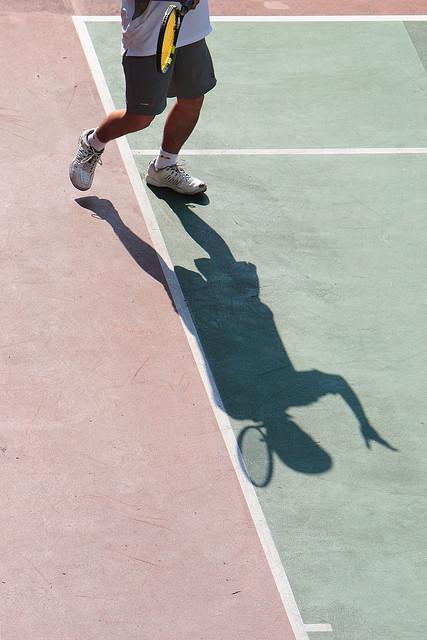How many black cat are this image?
Give a very brief answer. 0. 